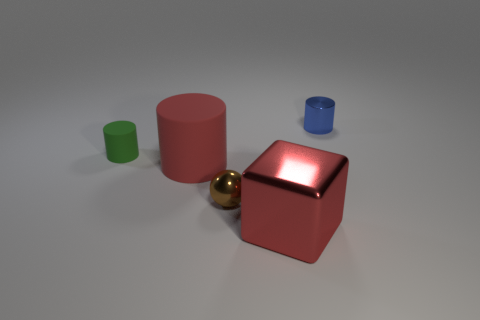Is there any other thing that is the same shape as the tiny brown thing?
Make the answer very short. No. There is a matte object that is the same color as the big metal thing; what is its shape?
Ensure brevity in your answer.  Cylinder. Is the number of small blue metal objects on the right side of the large cylinder the same as the number of shiny cylinders?
Ensure brevity in your answer.  Yes. What is the material of the blue cylinder that is on the right side of the small cylinder that is to the left of the small metallic object right of the big block?
Your answer should be very brief. Metal. What is the shape of the brown thing that is the same material as the blue cylinder?
Offer a terse response. Sphere. Is there any other thing that is the same color as the small rubber cylinder?
Your response must be concise. No. There is a tiny metal object in front of the large red cylinder to the right of the tiny green cylinder; what number of matte things are behind it?
Offer a very short reply. 2. How many red objects are either large metal cylinders or large metallic cubes?
Your response must be concise. 1. Does the metallic cube have the same size as the red thing left of the tiny brown metallic object?
Provide a succinct answer. Yes. There is a small green thing that is the same shape as the large red matte object; what material is it?
Make the answer very short. Rubber. 